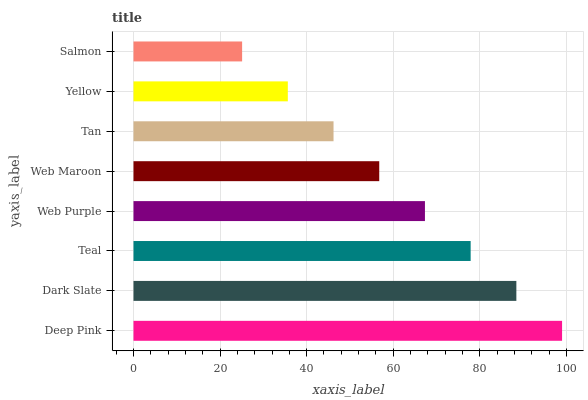Is Salmon the minimum?
Answer yes or no. Yes. Is Deep Pink the maximum?
Answer yes or no. Yes. Is Dark Slate the minimum?
Answer yes or no. No. Is Dark Slate the maximum?
Answer yes or no. No. Is Deep Pink greater than Dark Slate?
Answer yes or no. Yes. Is Dark Slate less than Deep Pink?
Answer yes or no. Yes. Is Dark Slate greater than Deep Pink?
Answer yes or no. No. Is Deep Pink less than Dark Slate?
Answer yes or no. No. Is Web Purple the high median?
Answer yes or no. Yes. Is Web Maroon the low median?
Answer yes or no. Yes. Is Yellow the high median?
Answer yes or no. No. Is Deep Pink the low median?
Answer yes or no. No. 